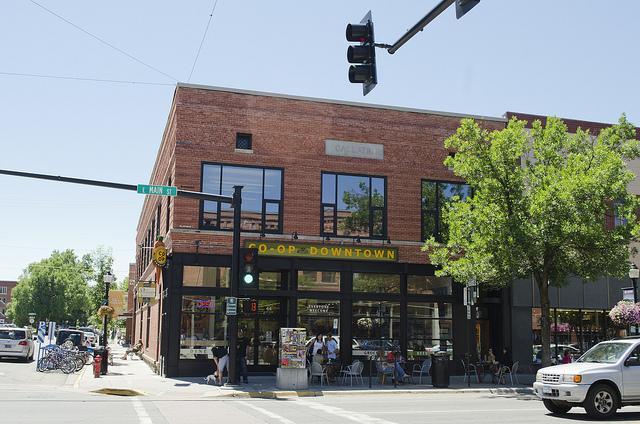How many trees are in front of the co-op?
Keep it brief. 1. What color is the dog?
Concise answer only. White. What kind of business is the corner store?
Give a very brief answer. Co-op. Is this a busy intersection?
Be succinct. No. Can that car make a left?
Be succinct. Yes. What is the name of the street?
Quick response, please. Main. What brand name is prominently featured in this photo?
Write a very short answer. Co op downtown. What is the name of the bank?
Write a very short answer. Co-op downtown. What color is the traffic light?
Answer briefly. Green. Is the building of a modern design?
Be succinct. Yes. Are the weather conditions sunny or overcast?
Short answer required. Sunny. 